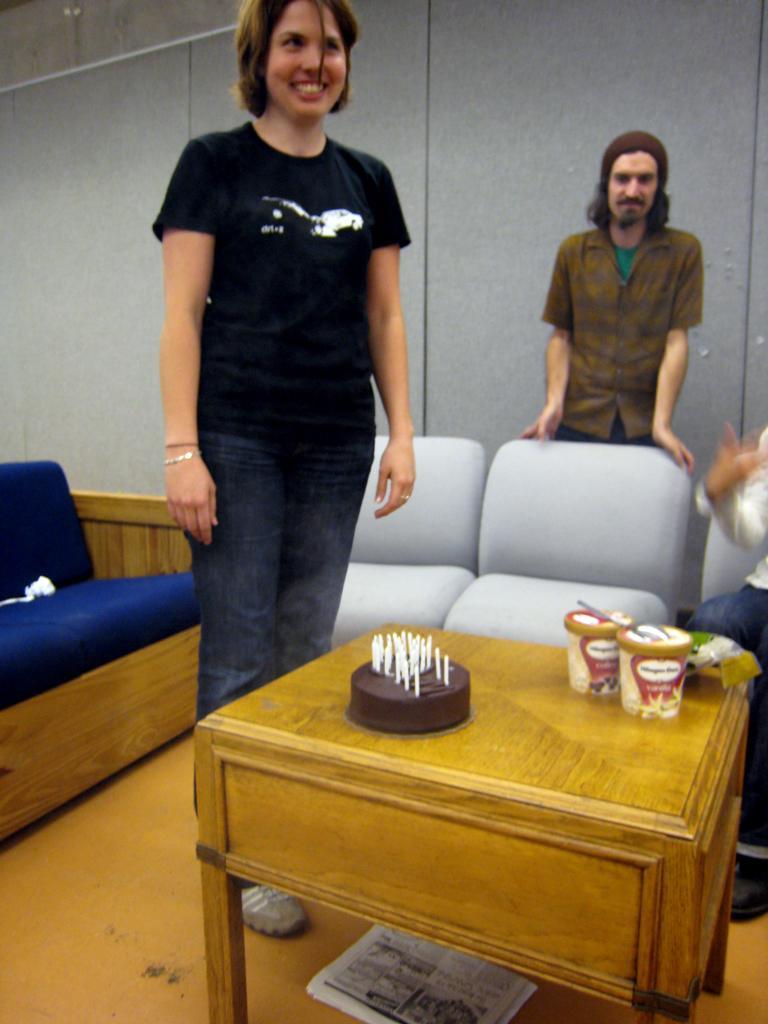Could you give a brief overview of what you see in this image? In this image i can see a woman and a man standing. I can see a table on which there is a cake and few containers. In the background i can see few couches and the wall. 